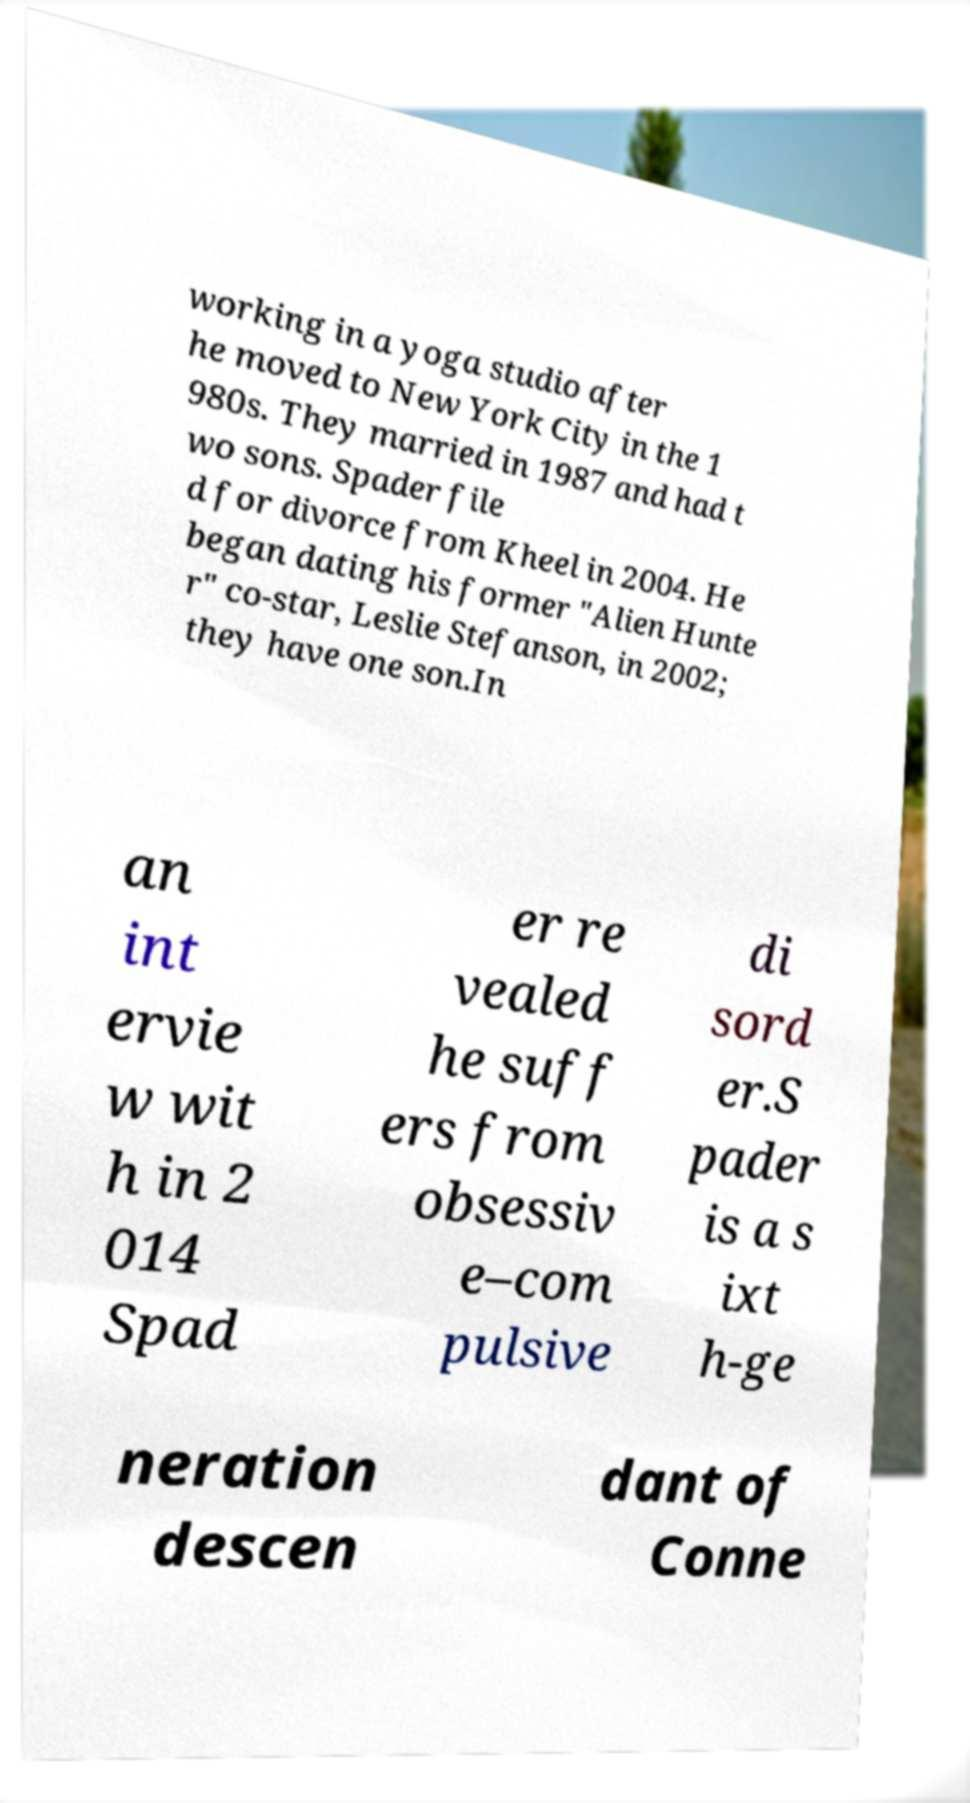There's text embedded in this image that I need extracted. Can you transcribe it verbatim? working in a yoga studio after he moved to New York City in the 1 980s. They married in 1987 and had t wo sons. Spader file d for divorce from Kheel in 2004. He began dating his former "Alien Hunte r" co-star, Leslie Stefanson, in 2002; they have one son.In an int ervie w wit h in 2 014 Spad er re vealed he suff ers from obsessiv e–com pulsive di sord er.S pader is a s ixt h-ge neration descen dant of Conne 